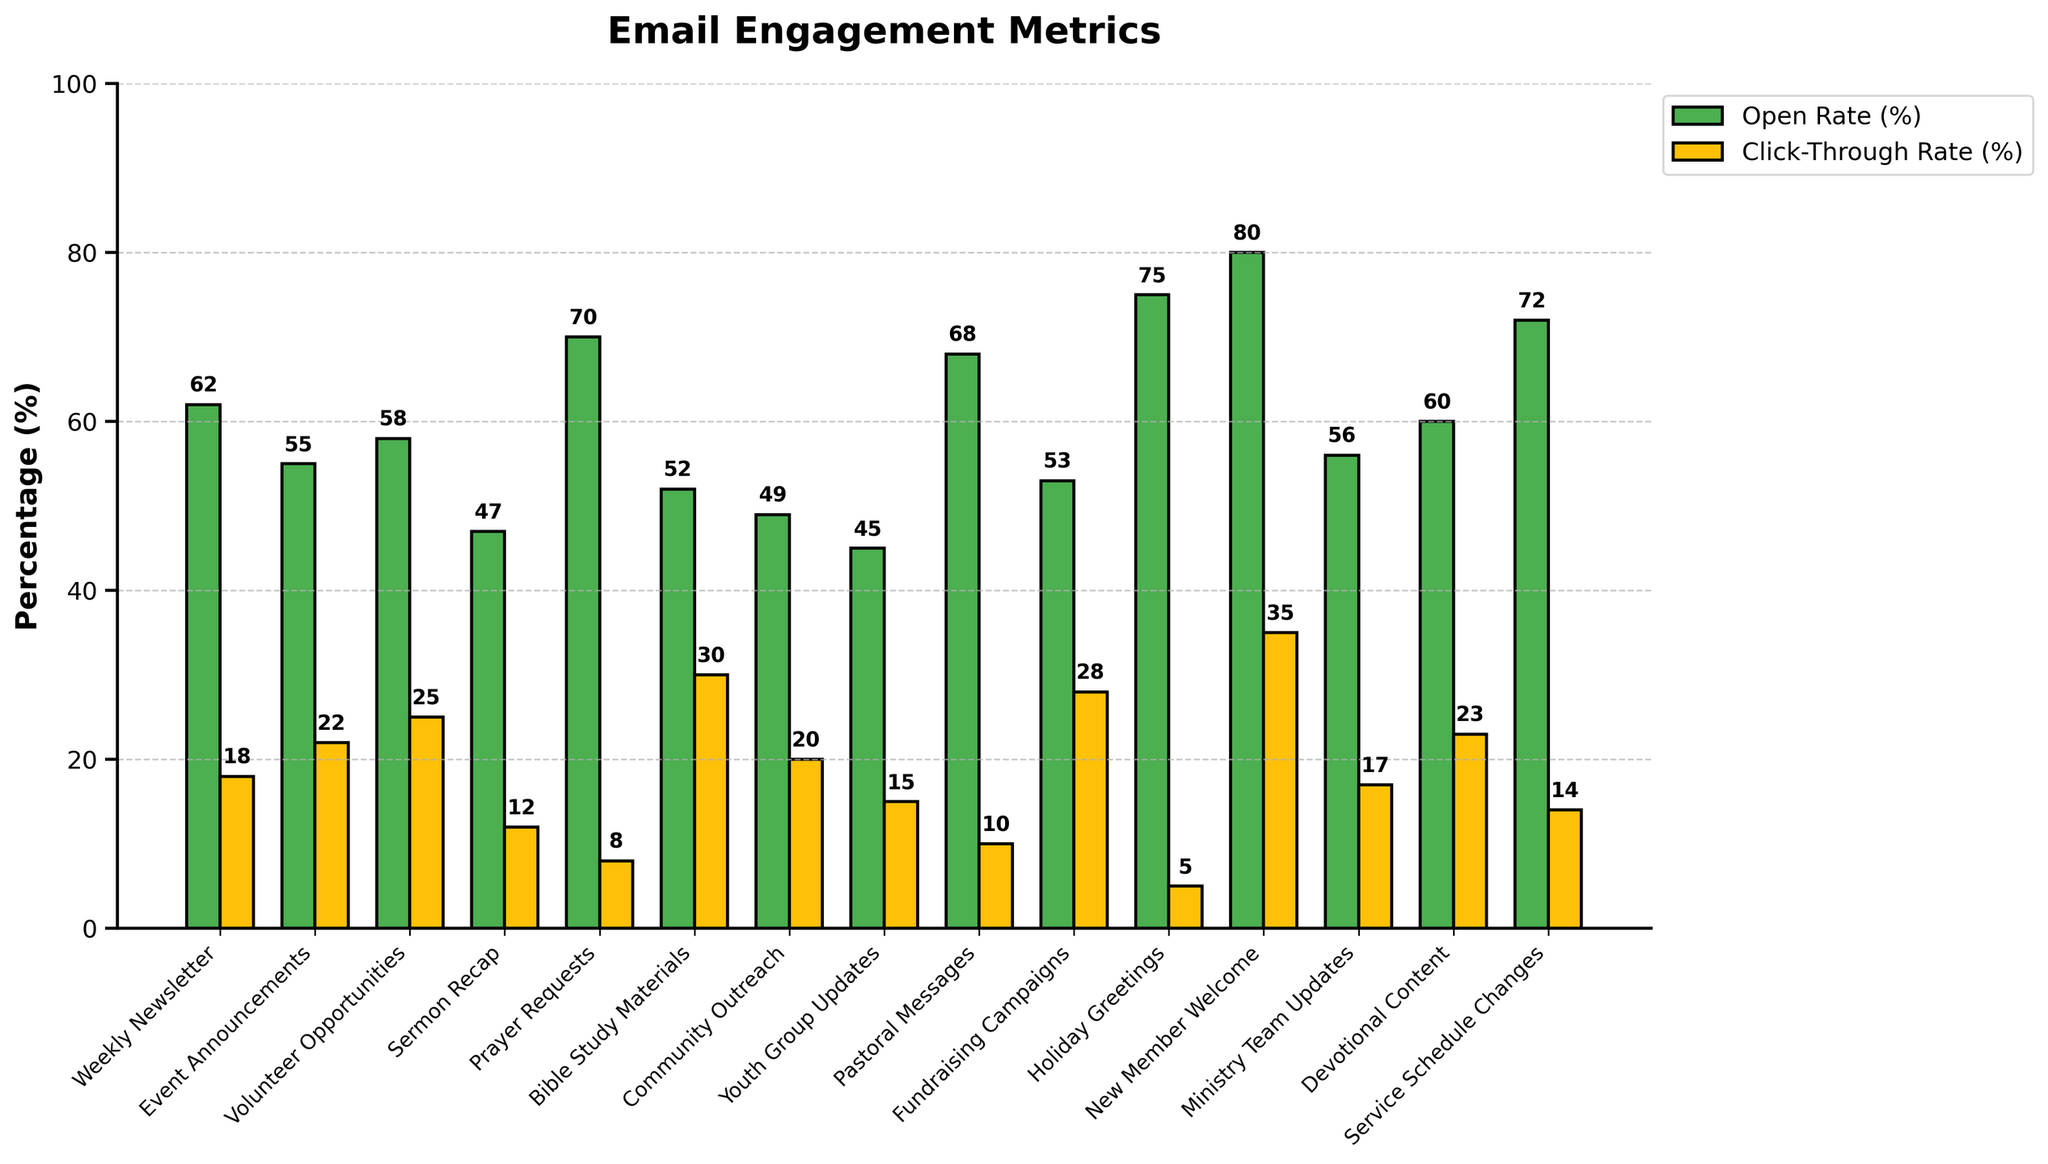What's the email type with the highest open rate? The open rates are represented by green bars. By comparing the heights, "New Member Welcome" has the tallest green bar, representing the highest open rate of 80%.
Answer: New Member Welcome Which email type has the lowest click-through rate? The click-through rates are represented by yellow bars. The shortest yellow bar is for "Holiday Greetings," indicating the lowest click-through rate of 5%.
Answer: Holiday Greetings What is the difference between the open rate and click-through rate for "Volunteer Opportunities"? The open rate for "Volunteer Opportunities" is 58%, and the click-through rate is 25%. Subtracting the click-through rate from the open rate: 58% - 25% = 33%.
Answer: 33% How many email types have an open rate above 60%? The open rates higher than 60% are represented by "Weekly Newsletter" (62%), "Prayer Requests" (70%), "Pastoral Messages" (68%), "New Member Welcome" (80%), and "Service Schedule Changes" (72%). Counting them gives 5 email types.
Answer: 5 Which email has both an open rate and click-through rate above 30%? Reviewing all email types, "New Member Welcome" has an open rate of 80% and a click-through rate of 35%, both above 30%.
Answer: New Member Welcome What is the average click-through rate for "Bible Study Materials" and "Fundraising Campaigns"? "Bible Study Materials" has a click-through rate of 30%, and "Fundraising Campaigns" has 28%. The average is calculated as (30% + 28%) / 2 = 58% / 2 = 29%.
Answer: 29% Which email type has a higher open rate: "Sermon Recap" or "Youth Group Updates"? The green bar for "Sermon Recap" indicates an open rate of 47%, and "Youth Group Updates" has an open rate of 45%. Comparing the two values, "Sermon Recap" is higher.
Answer: Sermon Recap What's the combined click-through rate for "Event Announcements" and "Devotional Content"? The click-through rates are 22% for "Event Announcements" and 23% for "Devotional Content". Adding these rates: 22% + 23% = 45%.
Answer: 45% Which email type has a higher click-through rate than its open rate? Checking each email type, none have a click-through rate higher than their open rate. All click-through rates are lower.
Answer: None Which email type has both its open rate and click-through rate above 20%? "Volunteer Opportunities" (58% open, 25% click-through), "Fundraising Campaigns" (53% open, 28% click-through), and "Devotional Content" (60% open, 23% click-through) have both rates above 20%.
Answer: Volunteer Opportunities, Fundraising Campaigns, Devotional Content 